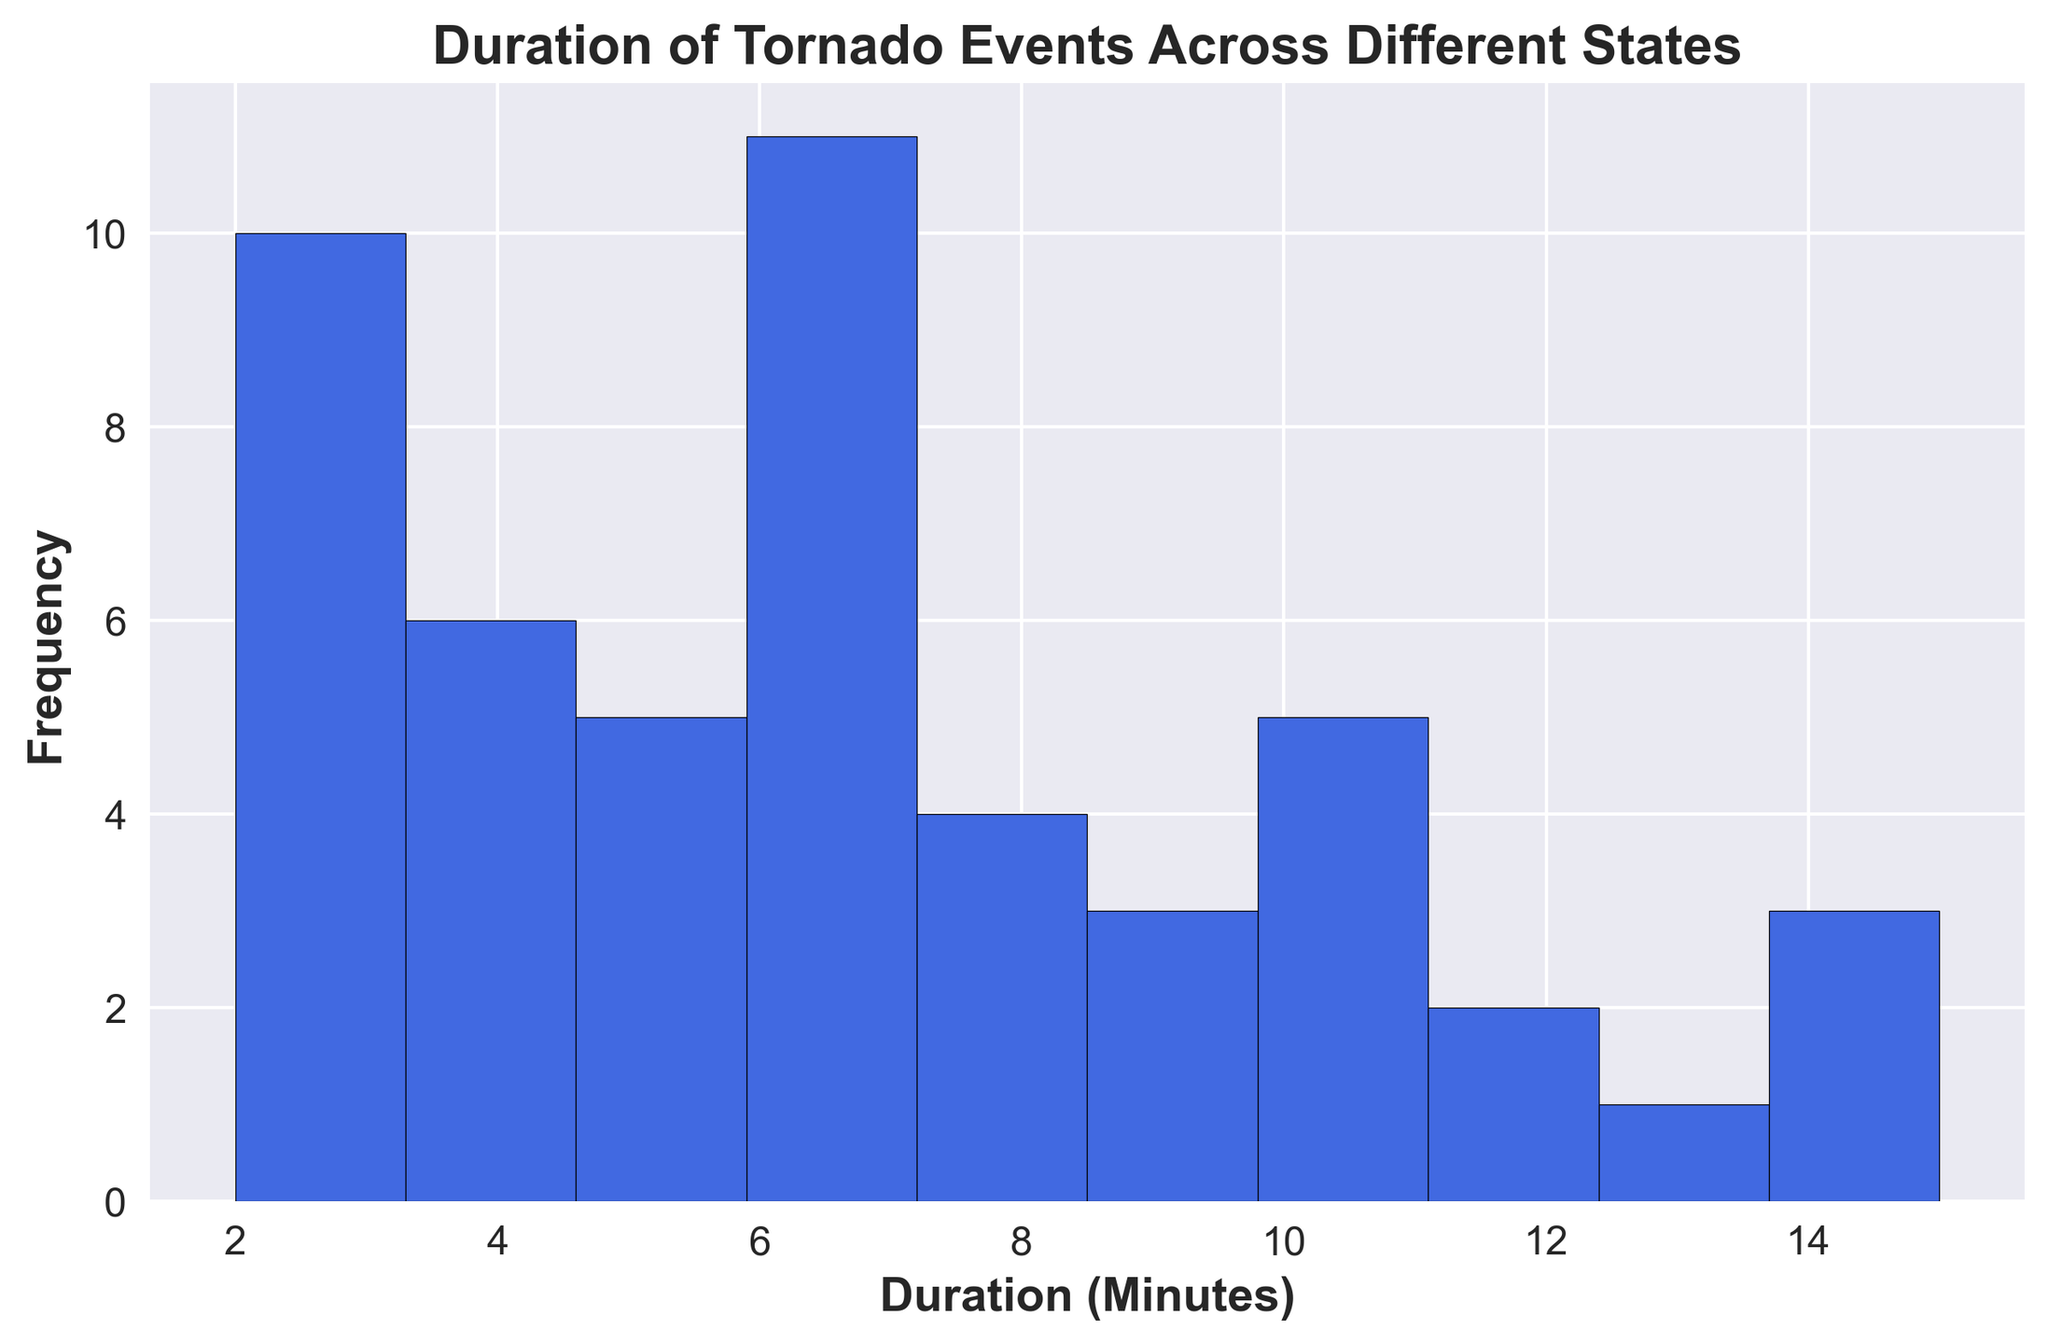What is the most common duration range for tornado events? The tallest bar in the histogram represents the most frequent duration range. By identifying this bar, one can see the duration range with the highest frequency of tornado events.
Answer: 3-5 minutes Which duration range has the fewest tornado events? The shortest bar in the histogram indicates the duration range with the fewest tornado events. By locating this bar, one can determine which range has the minimum frequency.
Answer: 16-18 minutes How many tornado events lasted between 6 and 8 minutes? Count the height of the bar in the histogram for the duration range of 6-8 minutes. This height represents the number of tornado events in that range.
Answer: Eight Are there more tornado events lasting less than 5 minutes or more than 12 minutes? Compare the combined height of the bars for tornado durations less than 5 minutes with the combined height of the bars for tornado durations greater than 12 minutes.
Answer: Less than 5 minutes What can be said about the frequency distribution of tornado durations? By observing the overall shape and spread of the bars in the histogram, one can comment on the distribution pattern. Check for any noticeable skewness, concentration of frequencies, or outliers.
Answer: Skewed towards shorter durations What is the approximate average duration for tornado events? Look at the center of the distribution of bars in the histogram and estimate the average based on the spread and height of the bars. Calculate an average around the midpoint of the highest clusters.
Answer: Approx. 7 minutes Which duration range has the second-highest frequency of tornado events? Identify the second tallest bar in the histogram and note the duration range it represents. This will give the second most frequent range.
Answer: 8-10 minutes How many tornado events lasted more than 10 minutes? Sum the heights of the bars in the histogram for all range bins above 10 minutes. This totals the frequency of tornado events longer than 10 minutes.
Answer: Thirteen 